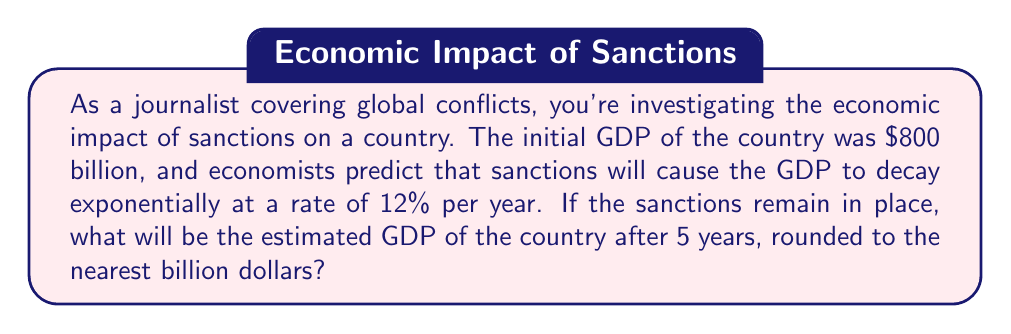Can you answer this question? To solve this problem, we'll use the exponential decay function:

$$A(t) = A_0 \cdot e^{-rt}$$

Where:
$A(t)$ is the GDP after time $t$
$A_0$ is the initial GDP
$r$ is the decay rate
$t$ is the time in years

Given:
$A_0 = 800$ billion dollars
$r = 0.12$ (12% per year)
$t = 5$ years

Step 1: Substitute the values into the exponential decay function:
$$A(5) = 800 \cdot e^{-0.12 \cdot 5}$$

Step 2: Simplify the exponent:
$$A(5) = 800 \cdot e^{-0.6}$$

Step 3: Calculate the value of $e^{-0.6}$:
$$e^{-0.6} \approx 0.5488$$

Step 4: Multiply by the initial GDP:
$$A(5) = 800 \cdot 0.5488 \approx 439.04$$

Step 5: Round to the nearest billion:
$$A(5) \approx 439 \text{ billion dollars}$$
Answer: $439 billion 